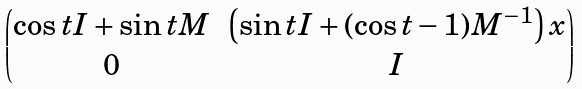Convert formula to latex. <formula><loc_0><loc_0><loc_500><loc_500>\begin{pmatrix} \cos { t } I + \sin { t M } & \left ( \sin { t } I + ( \cos { t } - 1 ) M ^ { - 1 } \right ) x \\ 0 & I \end{pmatrix}</formula> 